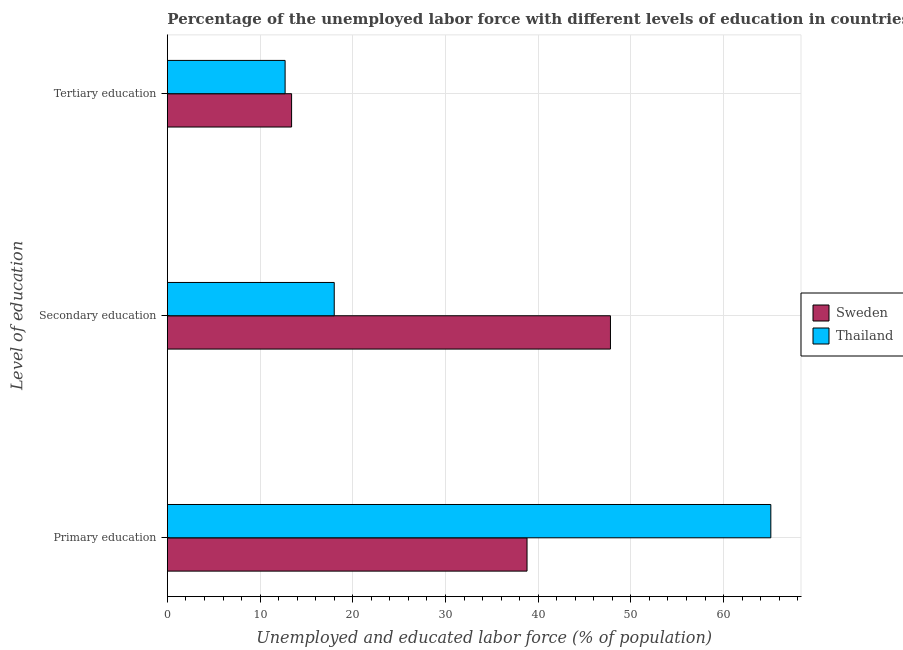How many different coloured bars are there?
Make the answer very short. 2. How many groups of bars are there?
Ensure brevity in your answer.  3. Are the number of bars per tick equal to the number of legend labels?
Keep it short and to the point. Yes. How many bars are there on the 1st tick from the top?
Ensure brevity in your answer.  2. What is the percentage of labor force who received tertiary education in Thailand?
Offer a very short reply. 12.7. Across all countries, what is the maximum percentage of labor force who received primary education?
Your answer should be compact. 65.1. Across all countries, what is the minimum percentage of labor force who received primary education?
Your response must be concise. 38.8. In which country was the percentage of labor force who received primary education maximum?
Make the answer very short. Thailand. In which country was the percentage of labor force who received tertiary education minimum?
Provide a short and direct response. Thailand. What is the total percentage of labor force who received tertiary education in the graph?
Give a very brief answer. 26.1. What is the difference between the percentage of labor force who received primary education in Thailand and that in Sweden?
Your answer should be compact. 26.3. What is the difference between the percentage of labor force who received tertiary education in Sweden and the percentage of labor force who received primary education in Thailand?
Provide a short and direct response. -51.7. What is the average percentage of labor force who received primary education per country?
Provide a short and direct response. 51.95. What is the difference between the percentage of labor force who received secondary education and percentage of labor force who received primary education in Thailand?
Your answer should be very brief. -47.1. What is the ratio of the percentage of labor force who received primary education in Thailand to that in Sweden?
Your response must be concise. 1.68. Is the difference between the percentage of labor force who received tertiary education in Sweden and Thailand greater than the difference between the percentage of labor force who received secondary education in Sweden and Thailand?
Provide a succinct answer. No. What is the difference between the highest and the second highest percentage of labor force who received secondary education?
Keep it short and to the point. 29.8. What is the difference between the highest and the lowest percentage of labor force who received secondary education?
Your response must be concise. 29.8. What does the 2nd bar from the top in Tertiary education represents?
Offer a very short reply. Sweden. What does the 1st bar from the bottom in Secondary education represents?
Ensure brevity in your answer.  Sweden. Is it the case that in every country, the sum of the percentage of labor force who received primary education and percentage of labor force who received secondary education is greater than the percentage of labor force who received tertiary education?
Ensure brevity in your answer.  Yes. What is the difference between two consecutive major ticks on the X-axis?
Make the answer very short. 10. Are the values on the major ticks of X-axis written in scientific E-notation?
Offer a very short reply. No. How many legend labels are there?
Give a very brief answer. 2. How are the legend labels stacked?
Your answer should be compact. Vertical. What is the title of the graph?
Your response must be concise. Percentage of the unemployed labor force with different levels of education in countries. Does "Netherlands" appear as one of the legend labels in the graph?
Ensure brevity in your answer.  No. What is the label or title of the X-axis?
Your answer should be very brief. Unemployed and educated labor force (% of population). What is the label or title of the Y-axis?
Your response must be concise. Level of education. What is the Unemployed and educated labor force (% of population) of Sweden in Primary education?
Keep it short and to the point. 38.8. What is the Unemployed and educated labor force (% of population) in Thailand in Primary education?
Keep it short and to the point. 65.1. What is the Unemployed and educated labor force (% of population) of Sweden in Secondary education?
Provide a succinct answer. 47.8. What is the Unemployed and educated labor force (% of population) of Sweden in Tertiary education?
Provide a succinct answer. 13.4. What is the Unemployed and educated labor force (% of population) of Thailand in Tertiary education?
Offer a very short reply. 12.7. Across all Level of education, what is the maximum Unemployed and educated labor force (% of population) of Sweden?
Ensure brevity in your answer.  47.8. Across all Level of education, what is the maximum Unemployed and educated labor force (% of population) of Thailand?
Provide a short and direct response. 65.1. Across all Level of education, what is the minimum Unemployed and educated labor force (% of population) of Sweden?
Ensure brevity in your answer.  13.4. Across all Level of education, what is the minimum Unemployed and educated labor force (% of population) of Thailand?
Give a very brief answer. 12.7. What is the total Unemployed and educated labor force (% of population) of Thailand in the graph?
Keep it short and to the point. 95.8. What is the difference between the Unemployed and educated labor force (% of population) of Thailand in Primary education and that in Secondary education?
Provide a short and direct response. 47.1. What is the difference between the Unemployed and educated labor force (% of population) of Sweden in Primary education and that in Tertiary education?
Your answer should be very brief. 25.4. What is the difference between the Unemployed and educated labor force (% of population) of Thailand in Primary education and that in Tertiary education?
Provide a succinct answer. 52.4. What is the difference between the Unemployed and educated labor force (% of population) of Sweden in Secondary education and that in Tertiary education?
Your answer should be very brief. 34.4. What is the difference between the Unemployed and educated labor force (% of population) in Sweden in Primary education and the Unemployed and educated labor force (% of population) in Thailand in Secondary education?
Provide a succinct answer. 20.8. What is the difference between the Unemployed and educated labor force (% of population) of Sweden in Primary education and the Unemployed and educated labor force (% of population) of Thailand in Tertiary education?
Offer a terse response. 26.1. What is the difference between the Unemployed and educated labor force (% of population) in Sweden in Secondary education and the Unemployed and educated labor force (% of population) in Thailand in Tertiary education?
Offer a terse response. 35.1. What is the average Unemployed and educated labor force (% of population) in Sweden per Level of education?
Provide a succinct answer. 33.33. What is the average Unemployed and educated labor force (% of population) in Thailand per Level of education?
Your answer should be compact. 31.93. What is the difference between the Unemployed and educated labor force (% of population) of Sweden and Unemployed and educated labor force (% of population) of Thailand in Primary education?
Ensure brevity in your answer.  -26.3. What is the difference between the Unemployed and educated labor force (% of population) of Sweden and Unemployed and educated labor force (% of population) of Thailand in Secondary education?
Provide a succinct answer. 29.8. What is the ratio of the Unemployed and educated labor force (% of population) in Sweden in Primary education to that in Secondary education?
Offer a very short reply. 0.81. What is the ratio of the Unemployed and educated labor force (% of population) of Thailand in Primary education to that in Secondary education?
Offer a terse response. 3.62. What is the ratio of the Unemployed and educated labor force (% of population) of Sweden in Primary education to that in Tertiary education?
Keep it short and to the point. 2.9. What is the ratio of the Unemployed and educated labor force (% of population) of Thailand in Primary education to that in Tertiary education?
Give a very brief answer. 5.13. What is the ratio of the Unemployed and educated labor force (% of population) of Sweden in Secondary education to that in Tertiary education?
Your answer should be compact. 3.57. What is the ratio of the Unemployed and educated labor force (% of population) of Thailand in Secondary education to that in Tertiary education?
Provide a short and direct response. 1.42. What is the difference between the highest and the second highest Unemployed and educated labor force (% of population) of Sweden?
Provide a short and direct response. 9. What is the difference between the highest and the second highest Unemployed and educated labor force (% of population) in Thailand?
Give a very brief answer. 47.1. What is the difference between the highest and the lowest Unemployed and educated labor force (% of population) in Sweden?
Your answer should be very brief. 34.4. What is the difference between the highest and the lowest Unemployed and educated labor force (% of population) in Thailand?
Your answer should be compact. 52.4. 